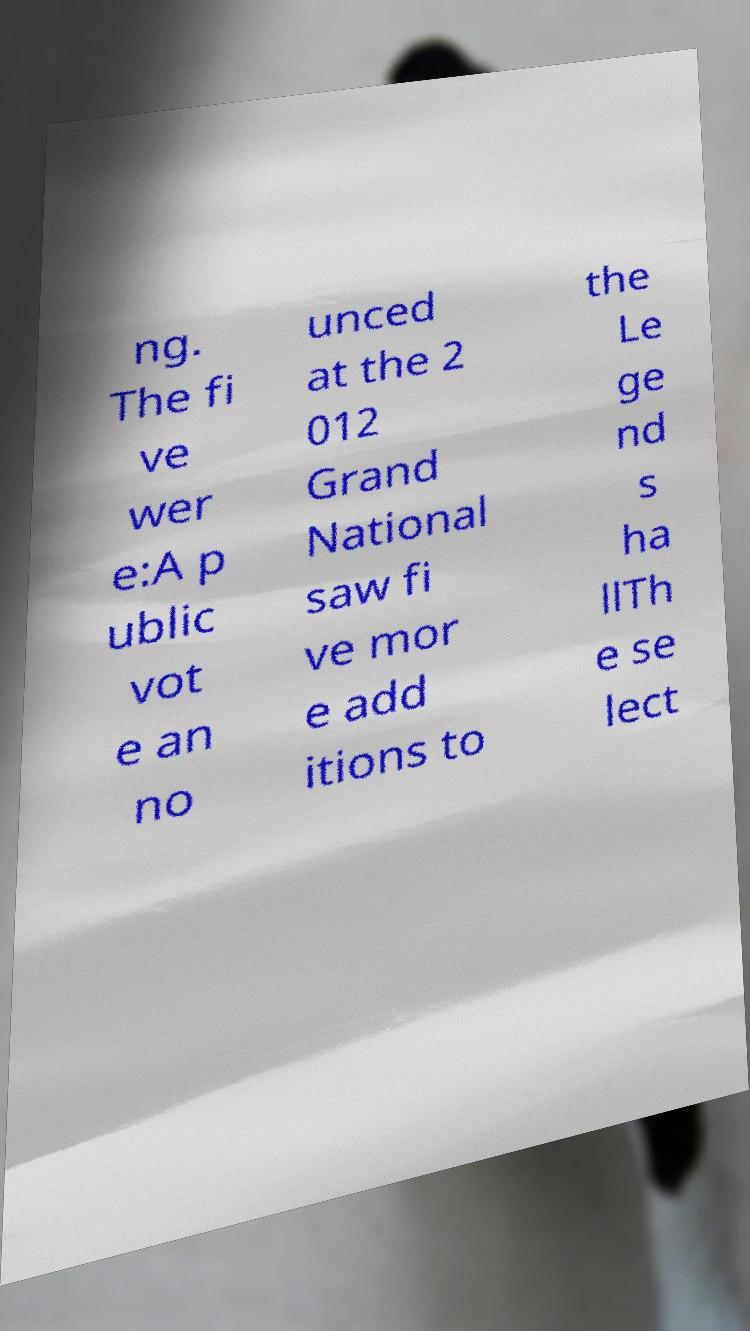There's text embedded in this image that I need extracted. Can you transcribe it verbatim? ng. The fi ve wer e:A p ublic vot e an no unced at the 2 012 Grand National saw fi ve mor e add itions to the Le ge nd s ha llTh e se lect 